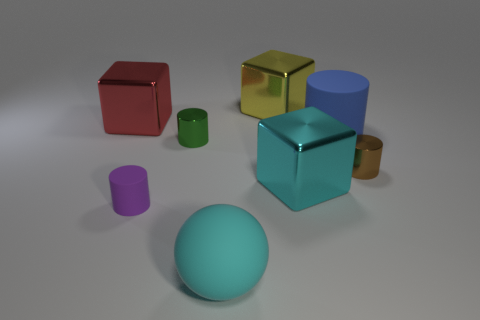Subtract all small brown cylinders. How many cylinders are left? 3 Add 1 cyan metal objects. How many objects exist? 9 Subtract all purple cylinders. How many cylinders are left? 3 Subtract all spheres. How many objects are left? 7 Subtract all yellow blocks. Subtract all big cyan things. How many objects are left? 5 Add 5 brown metallic cylinders. How many brown metallic cylinders are left? 6 Add 7 brown cylinders. How many brown cylinders exist? 8 Subtract 0 gray cylinders. How many objects are left? 8 Subtract all green spheres. Subtract all yellow blocks. How many spheres are left? 1 